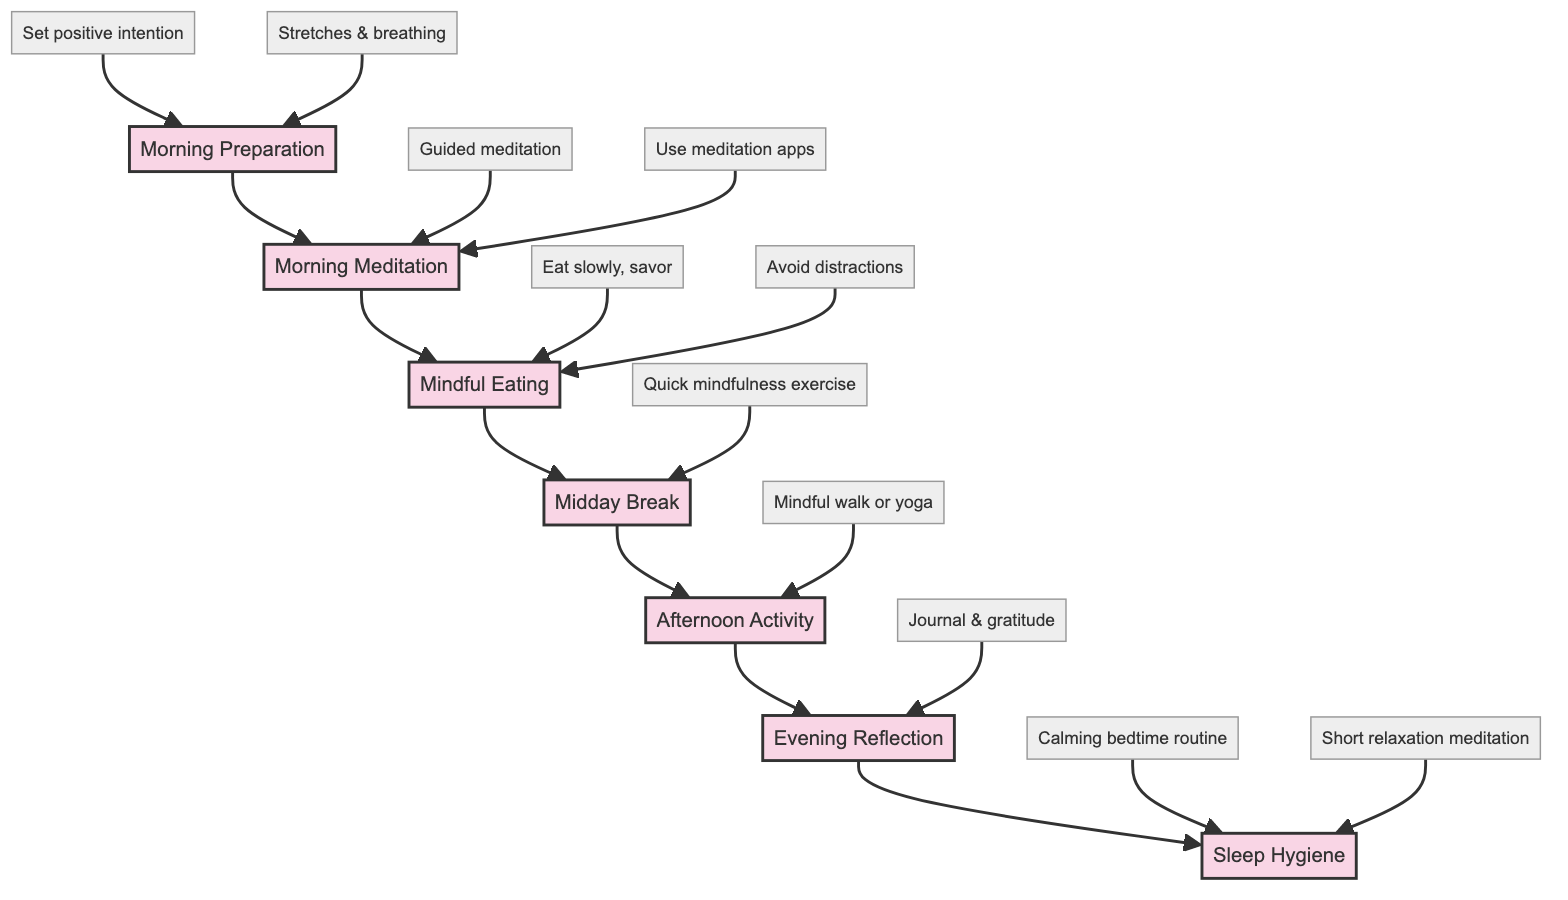What is the first step in the mindfulness routine? The diagram starts with the first step labeled "Morning Preparation." This is the initial action to be taken in the sequence.
Answer: Morning Preparation How many actions are associated with "Morning Meditation"? Under "Morning Meditation," there are three actions listed: sitting comfortably, focusing on breath, and using meditation apps. Counting them gives us a total of three actions.
Answer: 3 What does "Evening Reflection" encourage practitioners to do? "Evening Reflection" includes actions focused on journaling about the day and listing three things to be grateful for, indicating this step encourages reflective practices.
Answer: Journal about your day What is a common activity mentioned for the "Afternoon Activity" step? The "Afternoon Activity" step suggests going for a mindful walk or engaging in gentle yoga, emphasizing physical engagement with mindfulness.
Answer: Mindful walk or yoga What follows "Midday Break" in the mindfulness flow? Following "Midday Break" in the flow chart is the "Afternoon Activity" step, which indicates the next sequence in the mindfulness practice.
Answer: Afternoon Activity Which action should be taken during "Sleep Hygiene"? Under "Sleep Hygiene," one recommended action is to establish a calming bedtime routine, highlighting the importance of winding down before sleep.
Answer: Calming bedtime routine How are the steps in the diagram connected? The steps in the diagram are connected sequentially; each step leads to the next in a linear fashion, creating a flow from "Morning Preparation" to "Sleep Hygiene."
Answer: Sequentially connected What does the second action in "Morning Preparation" entail? The second action in "Morning Preparation" is performing basic stretches and breathing exercises, which focuses on physical readiness for the day.
Answer: Stretches & breathing 